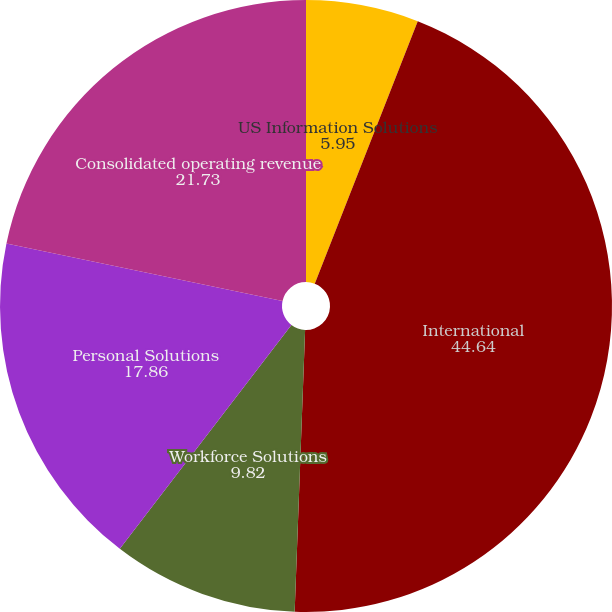Convert chart. <chart><loc_0><loc_0><loc_500><loc_500><pie_chart><fcel>US Information Solutions<fcel>International<fcel>Workforce Solutions<fcel>Personal Solutions<fcel>Consolidated operating revenue<nl><fcel>5.95%<fcel>44.64%<fcel>9.82%<fcel>17.86%<fcel>21.73%<nl></chart> 